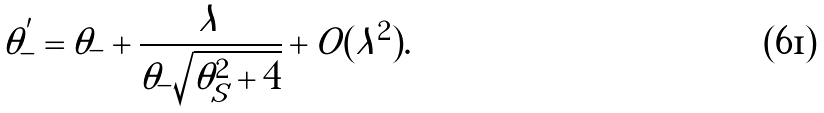Convert formula to latex. <formula><loc_0><loc_0><loc_500><loc_500>\tilde { \theta } _ { - } ^ { ^ { \prime } } = \tilde { \theta } _ { - } + \frac { \lambda } { \tilde { \theta } _ { - } \sqrt { \tilde { \theta } _ { S } ^ { 2 } + 4 } } + O ( \lambda ^ { 2 } ) .</formula> 